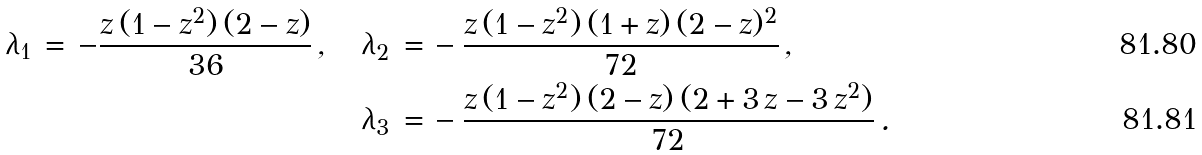<formula> <loc_0><loc_0><loc_500><loc_500>\lambda _ { 1 } \, = \, - \frac { z \, ( 1 - z ^ { 2 } ) \, ( 2 - z ) } { 3 6 } \, , \quad \lambda _ { 2 } \, = & \, - \frac { z \, ( 1 - z ^ { 2 } ) \, ( 1 + z ) \, ( 2 - z ) ^ { 2 } } { 7 2 } \, , \\ \lambda _ { 3 } \, = & \, - \frac { z \, ( 1 - z ^ { 2 } ) \, ( 2 - z ) \, ( 2 + 3 \, z - 3 \, z ^ { 2 } ) } { 7 2 } \, .</formula> 